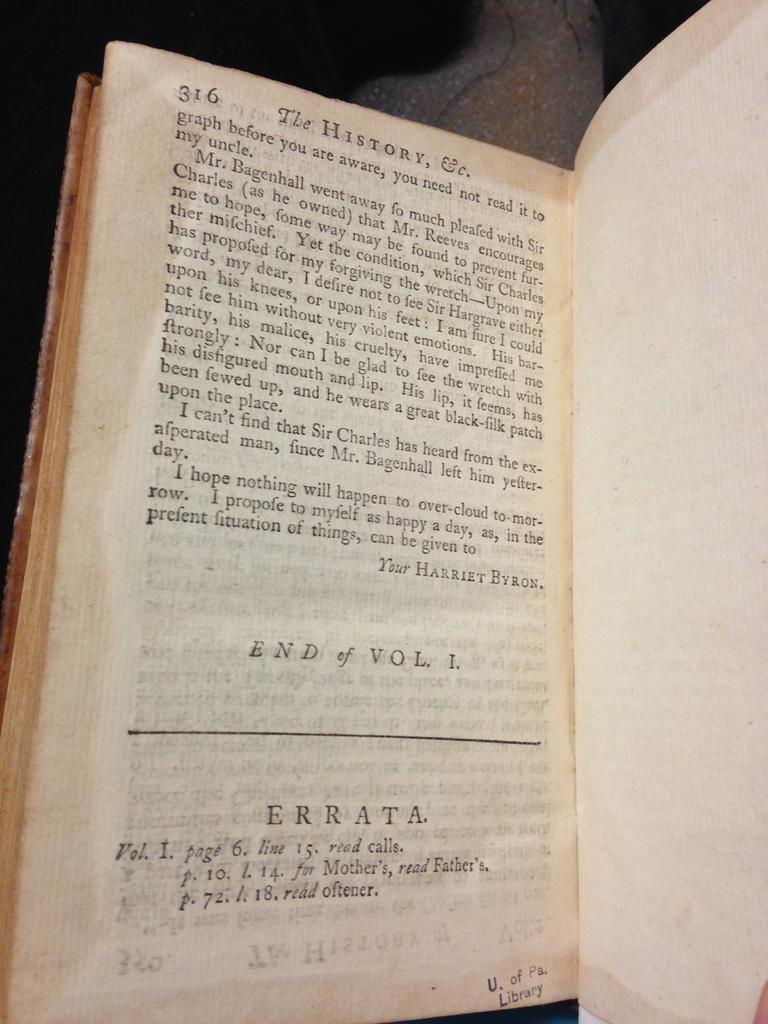<image>
Render a clear and concise summary of the photo. A book is opened to page 316 with Errata at the bottom of the page. 